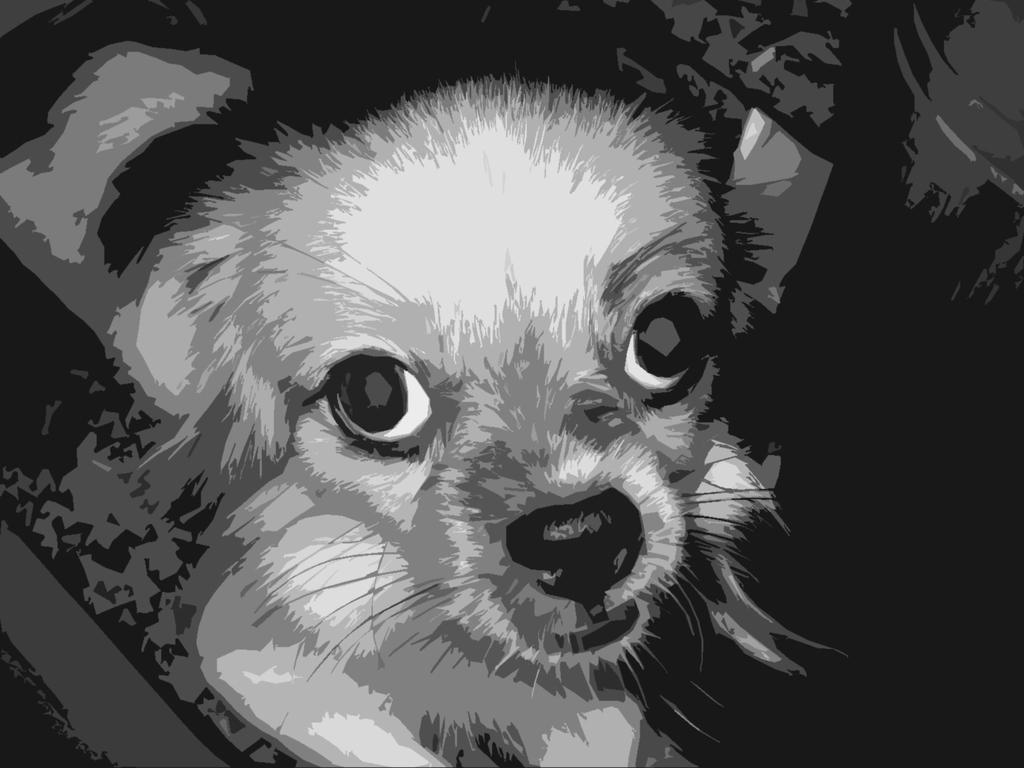What type of animal is present in the image? There is an animal in the image, but the specific type of animal cannot be determined from the provided fact. What statement does the animal make in the image? Animals do not make statements, as they are not capable of human language. 